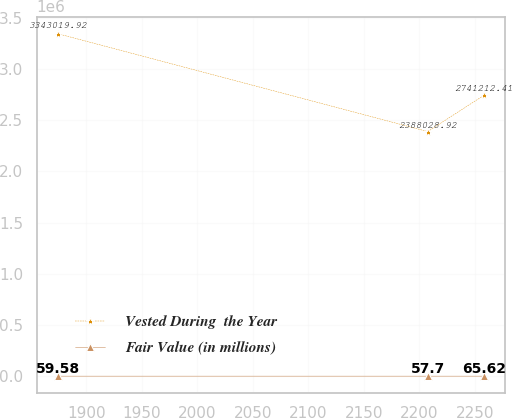Convert chart. <chart><loc_0><loc_0><loc_500><loc_500><line_chart><ecel><fcel>Vested During  the Year<fcel>Fair Value (in millions)<nl><fcel>1874.29<fcel>3.34302e+06<fcel>59.58<nl><fcel>2207.47<fcel>2.38803e+06<fcel>57.7<nl><fcel>2258.02<fcel>2.74121e+06<fcel>65.62<nl></chart> 